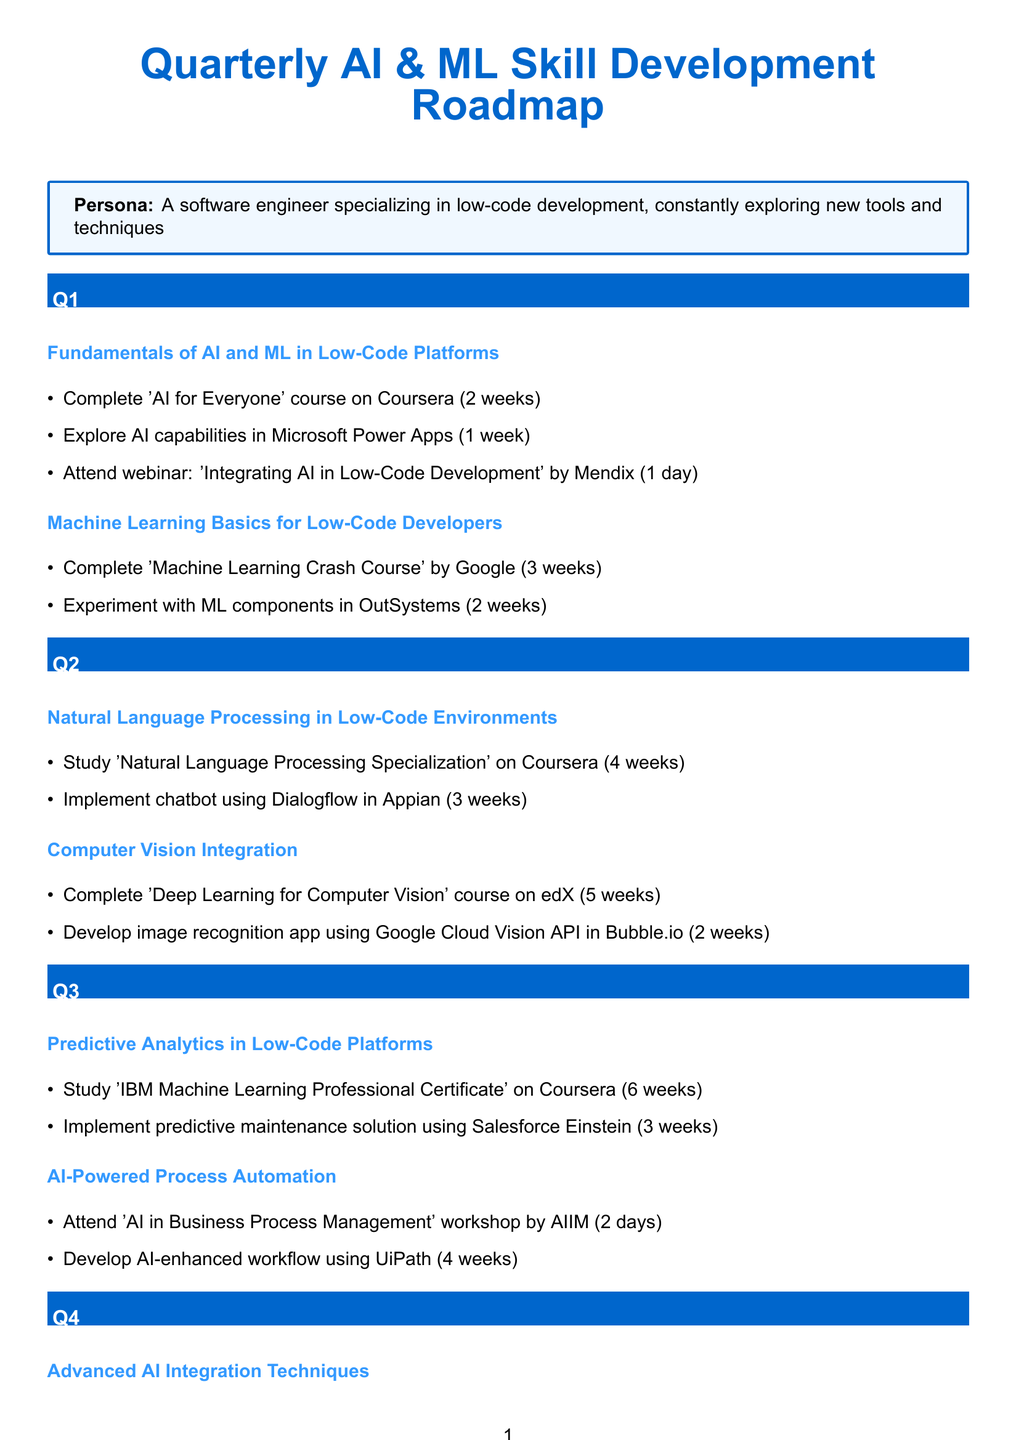What is the focus area for Q1? The document lists two focus areas for Q1. The first is "Fundamentals of AI and ML in Low-Code Platforms" and the second is "Machine Learning Basics for Low-Code Developers."
Answer: Fundamentals of AI and ML in Low-Code Platforms How long is the 'AI for Everyone' course? The document states the duration of the 'AI for Everyone' course, which is mentioned under Q1.
Answer: 2 weeks What activity is scheduled for Q3 related to predictive analytics? The document lists the activities under the focus area "Predictive Analytics in Low-Code Platforms" for Q3.
Answer: Study 'IBM Machine Learning Professional Certificate' on Coursera How many weeks does the 'Deep Learning Specialization' course take? The document specifies the duration of the 'Deep Learning Specialization' course under Q4.
Answer: 8 weeks Which platform is used for implementing a chatbot in Q2? The focus area in Q2 mentions the specific platform for developing the chatbot.
Answer: Appian What is the main focus area for Q4? The document outlines two main focus areas for Q4, the first being "Advanced AI Integration Techniques" and the second being "AI Ethics and Responsible Development."
Answer: Advanced AI Integration Techniques How many days is the 'AI in Business Process Management' workshop? The document specifies the duration of the workshop listed under Q3.
Answer: 2 days Which course covers ethics in AI? The document lists the course entitled 'AI Ethics: Global Perspectives' under Q4, which focuses on AI ethics.
Answer: AI Ethics: Global Perspectives 